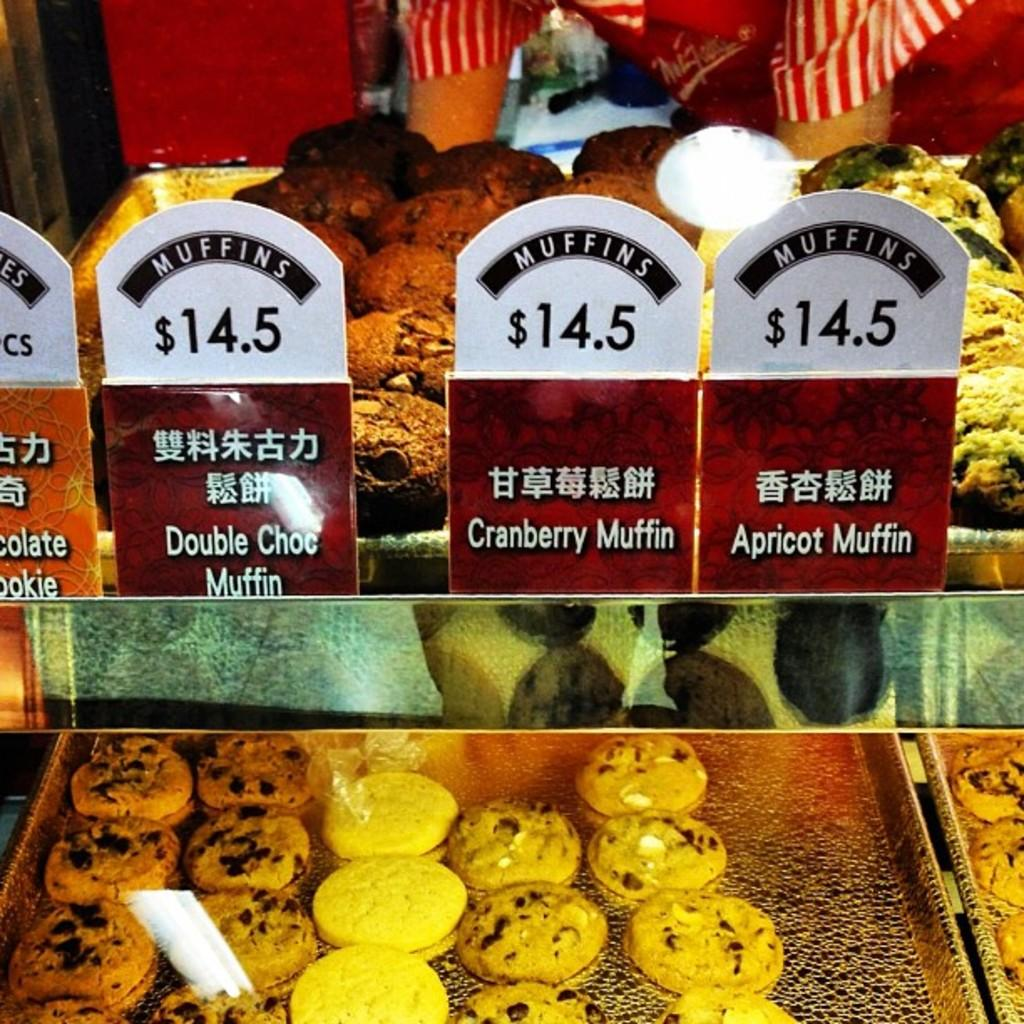What can be seen in the background of the image? There are hands of a person visible in the background. What is present on the trays in the image? There is food in the trays. How are the trays arranged in the image? The trays are placed on racks. What type of information is displayed on the boards in the image? The boards have some information, but the specific details are not mentioned in the facts. What type of beast can be seen playing the drum in the image? There is no beast or drum present in the image. What color is the neck of the person in the background? The facts do not mention the color of the person's neck, and it is not visible in the image. 